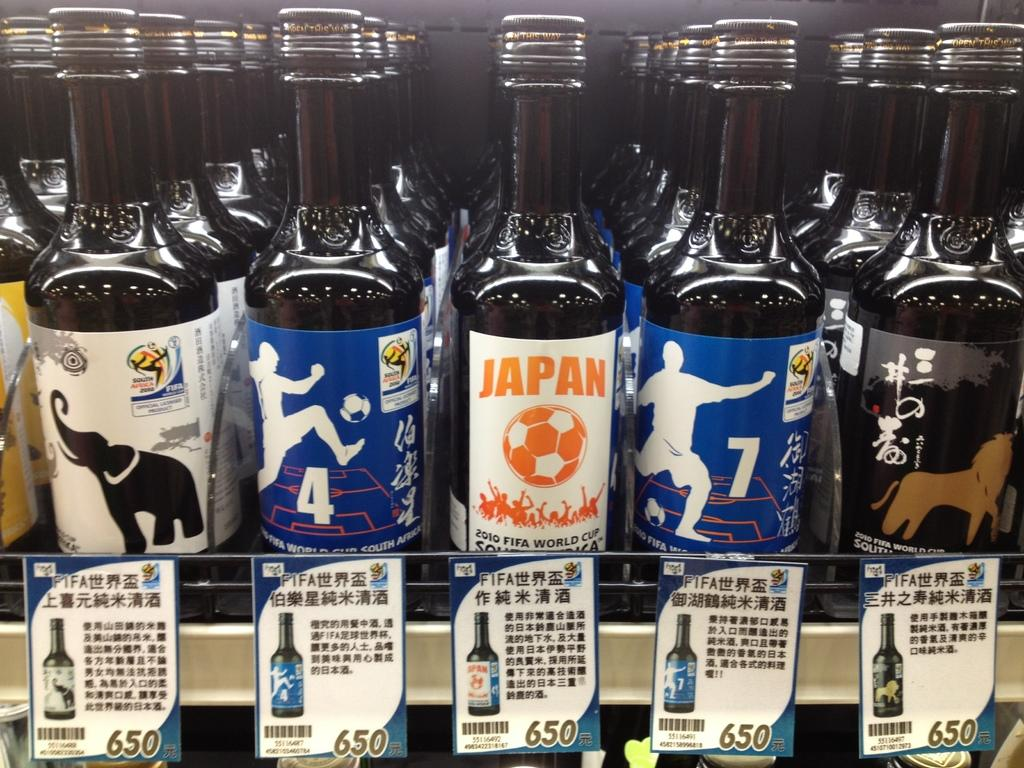<image>
Write a terse but informative summary of the picture. Many bottles of beer with the bottle in middle showing a label that says JAPAN 